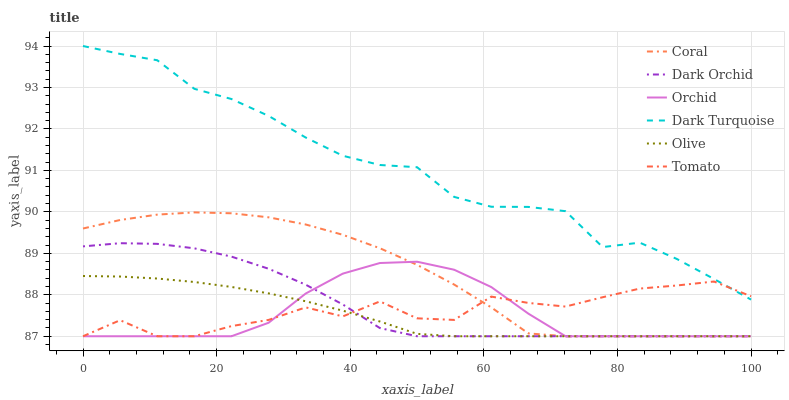Does Coral have the minimum area under the curve?
Answer yes or no. No. Does Coral have the maximum area under the curve?
Answer yes or no. No. Is Dark Turquoise the smoothest?
Answer yes or no. No. Is Dark Turquoise the roughest?
Answer yes or no. No. Does Dark Turquoise have the lowest value?
Answer yes or no. No. Does Coral have the highest value?
Answer yes or no. No. Is Coral less than Dark Turquoise?
Answer yes or no. Yes. Is Dark Turquoise greater than Dark Orchid?
Answer yes or no. Yes. Does Coral intersect Dark Turquoise?
Answer yes or no. No. 